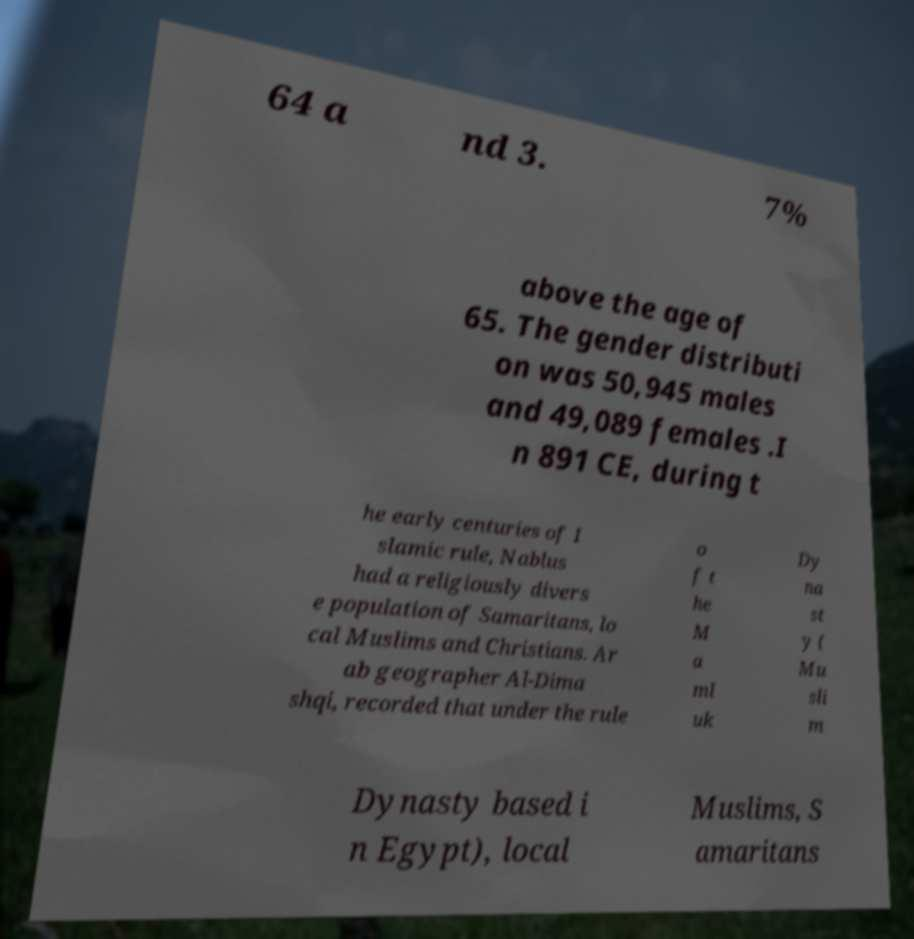Please read and relay the text visible in this image. What does it say? 64 a nd 3. 7% above the age of 65. The gender distributi on was 50,945 males and 49,089 females .I n 891 CE, during t he early centuries of I slamic rule, Nablus had a religiously divers e population of Samaritans, lo cal Muslims and Christians. Ar ab geographer Al-Dima shqi, recorded that under the rule o f t he M a ml uk Dy na st y ( Mu sli m Dynasty based i n Egypt), local Muslims, S amaritans 